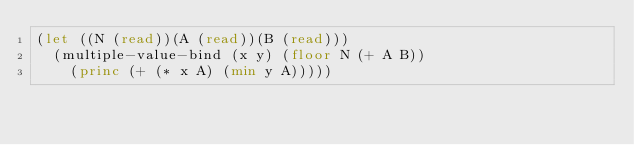<code> <loc_0><loc_0><loc_500><loc_500><_Lisp_>(let ((N (read))(A (read))(B (read)))
  (multiple-value-bind (x y) (floor N (+ A B))
    (princ (+ (* x A) (min y A)))))</code> 